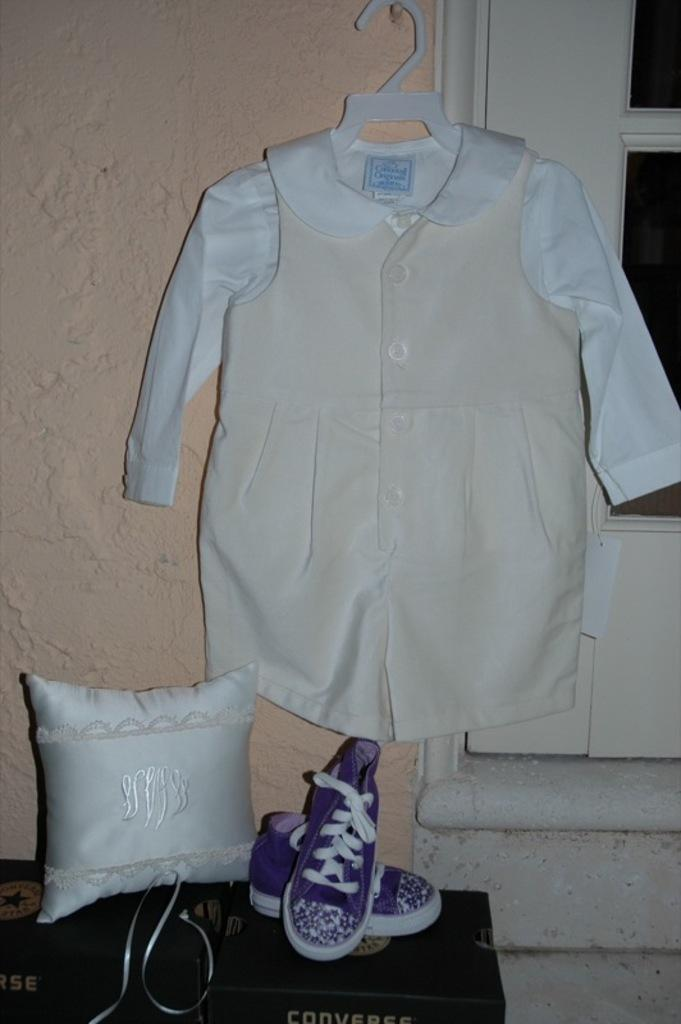What is hanging on the wall in the image? There is a dress hanging on the wall in the image. What is located beside the dress in the image? There is a door beside the dress in the image. What is placed below the dress in the image? There is a pair of shoes below the dress in the image. What can be seen on some objects in the image? Pillows are placed on some objects in the image. What type of tin can be seen being pulled by a monkey in the image? There is no tin or monkey present in the image. 